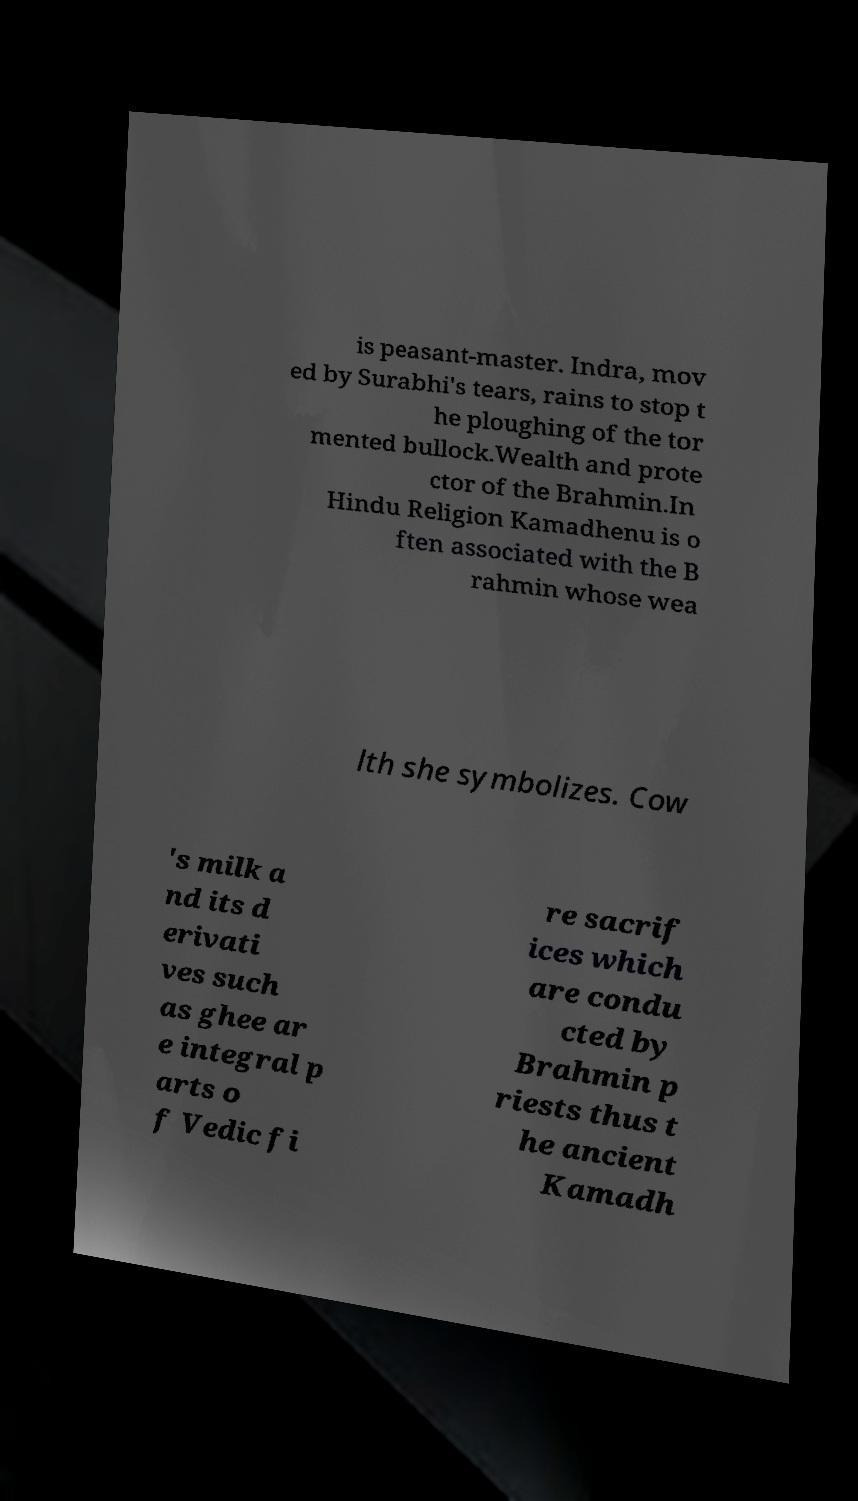Could you assist in decoding the text presented in this image and type it out clearly? is peasant-master. Indra, mov ed by Surabhi's tears, rains to stop t he ploughing of the tor mented bullock.Wealth and prote ctor of the Brahmin.In Hindu Religion Kamadhenu is o ften associated with the B rahmin whose wea lth she symbolizes. Cow 's milk a nd its d erivati ves such as ghee ar e integral p arts o f Vedic fi re sacrif ices which are condu cted by Brahmin p riests thus t he ancient Kamadh 